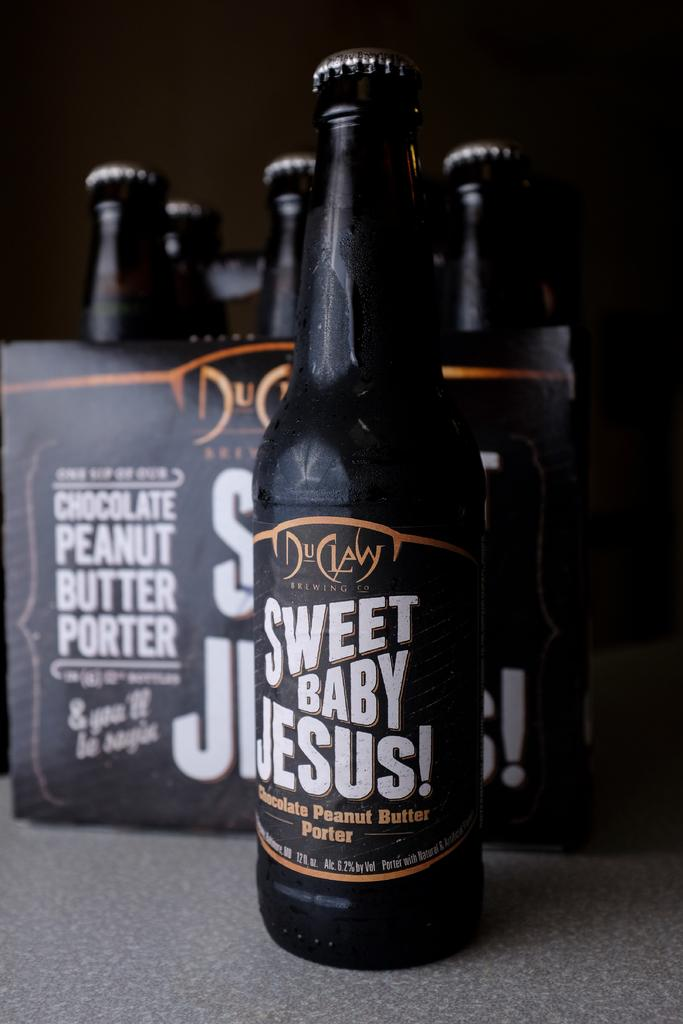<image>
Provide a brief description of the given image. Black bottle with a label that says "Sweet baby jesus" on it. 